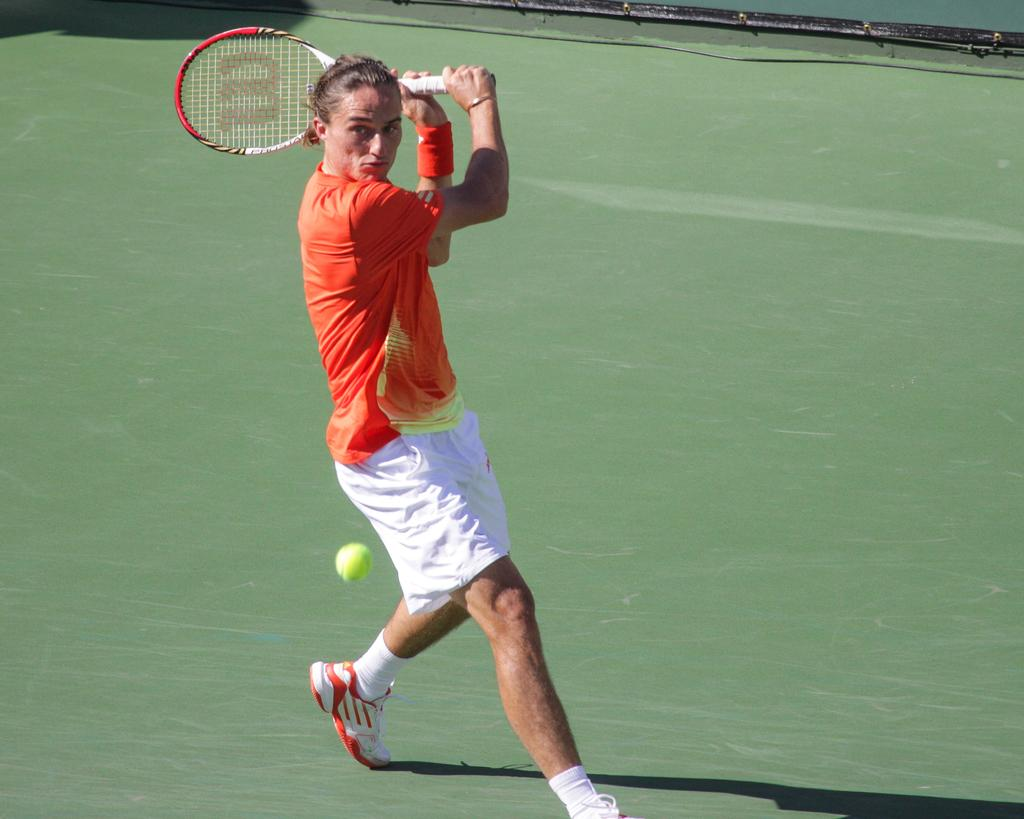What is the person in the image doing? The person is running and hitting a tennis ball. What equipment is the person using to hit the tennis ball? The person is using a tennis bat. What color is the person's T-shirt? The person is wearing an orange T-shirt. What type of shoes is the person wearing? The person is wearing white shoes. What clothing item is the person wearing on their feet along with the shoes? The person is wearing socks. What type of cactus can be seen in the image? There is no cactus present in the image; it features a person playing tennis. What dish is the person cooking in the image? There is no cooking or mention of food in the image; it focuses on a person playing tennis. 